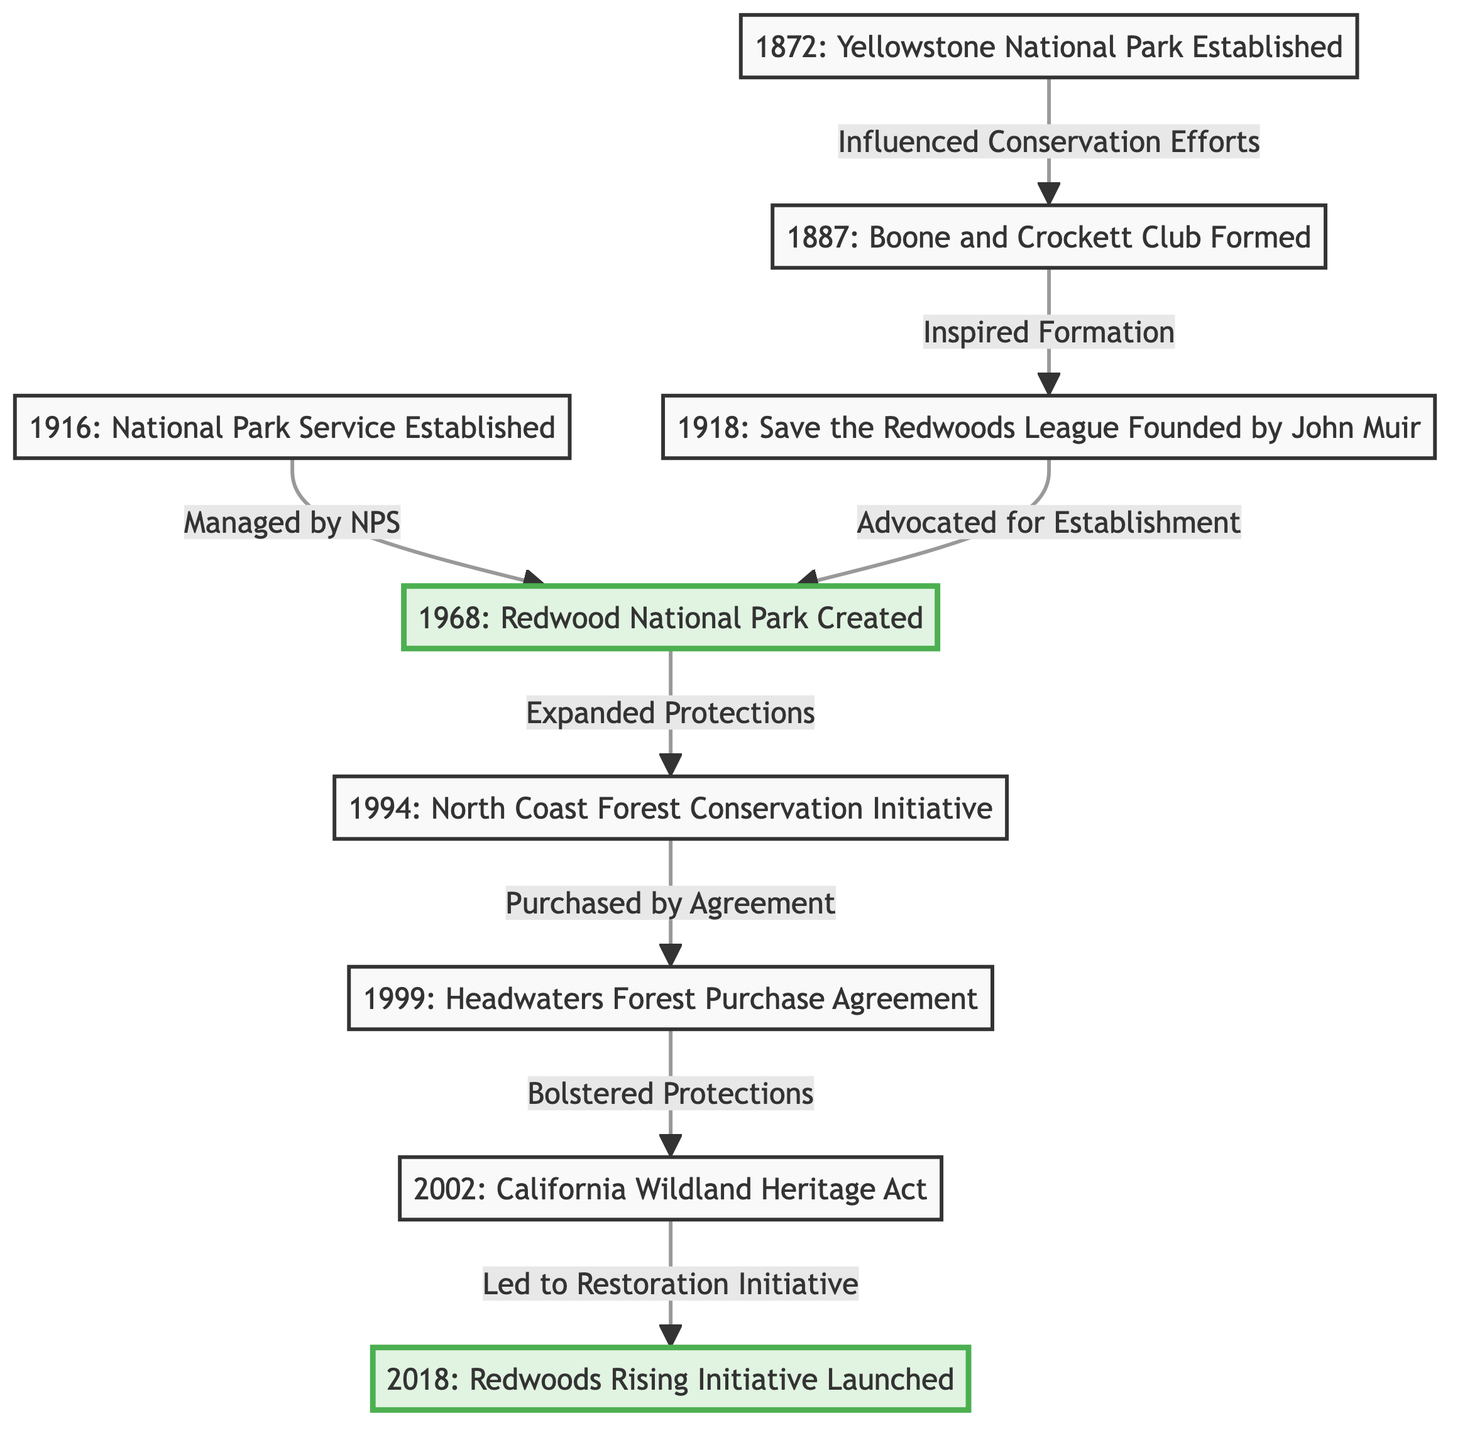What year was the Redwood National Park created? Looking at the diagram, the node for the Redwood National Park states "1968: Redwood National Park Created." Therefore, the year is explicitly mentioned next to the node.
Answer: 1968 What organization was founded by John Muir? The diagram shows a node labeled "1918: Save the Redwoods League Founded by John Muir." This indicates that the organization associated with John Muir is the Save the Redwoods League.
Answer: Save the Redwoods League How many key milestones are represented in the diagram? Counting all the nodes that represent significant milestones in conservation efforts, there are eight nodes present: Yellowstone Park, Boone and Crockett Club, Save the Redwoods League, National Park Service, Redwood National Park, North Coast Forest Conservation Initiative, Headwaters Forest Purchase Agreement, and California Wildland Heritage Act, and Redwoods Rising. Thus, the total number is eight.
Answer: 8 Which initiative was launched in 2018? The last node in the flowchart is "2018: Redwoods Rising Initiative Launched," explicitly stating the initiative and the year it was launched.
Answer: Redwoods Rising Initiative What was the relationship between the Headwaters Forest and the California Wildland Heritage Act? The diagram illustrates that the Headwaters Forest "Bolstered Protections" for the California Wildland Heritage Act. This means that the establishment or initiatives surrounding the Headwaters Forest increased the protections eventually leading to the California Wildland Heritage Act.
Answer: Bolstered Protections What did the Boone and Crockett Club inspire? According to the diagram, the Boone and Crockett Club "Inspired Formation" of the Save the Redwoods League. This indicates a direct influence from this club to the founding of another organization.
Answer: Formation Which milestone directly followed the expansion of protections in the North Coast Forest Conservation Initiative? The flowchart shows that after the North Coast Forest Conservation Initiative, the next milestone is the "1999: Headwaters Forest Purchase Agreement." This follows the direct flow from one node to the next, providing a clear sequence.
Answer: Headwaters Forest Purchase Agreement Who established the National Park Service? The diagram specifies "1916: National Park Service Established," indicating the establishment year but does not explicitly name individual founders. However, it is widely known that the government established the National Park Service, reflected in the node description.
Answer: National Park Service 